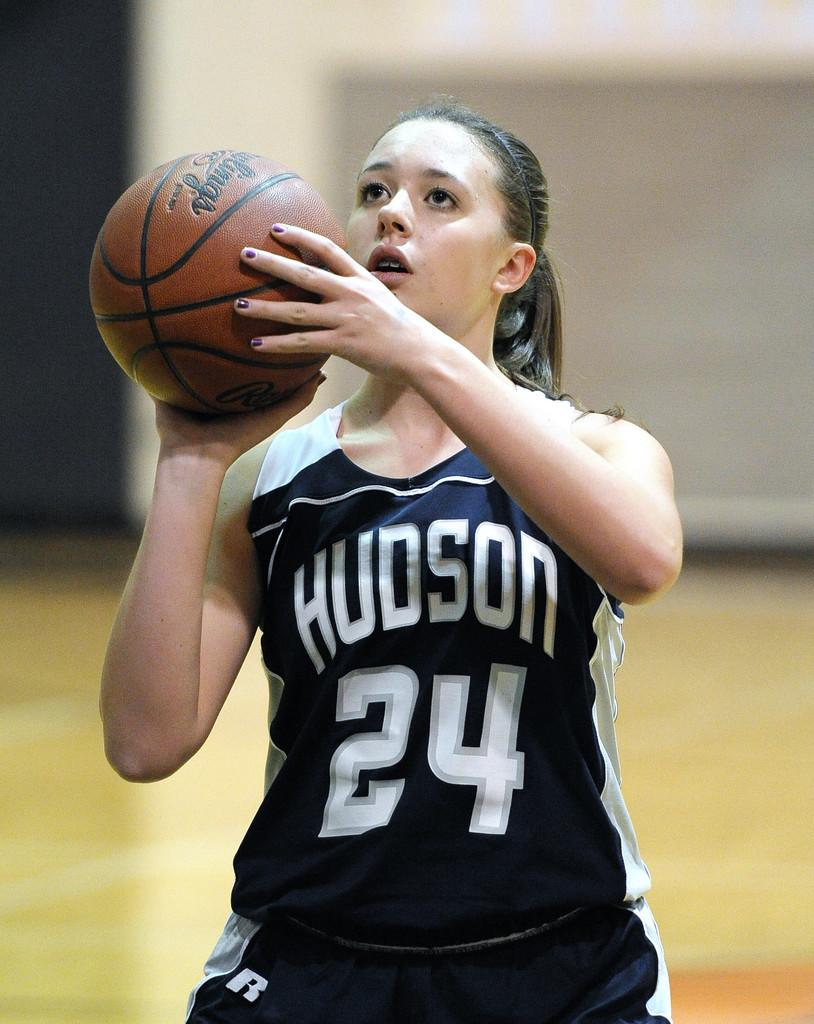Provide a one-sentence caption for the provided image. A young lady wearing a blue top with Hudson and the number 24 on it, prepares to throw the basketball. 